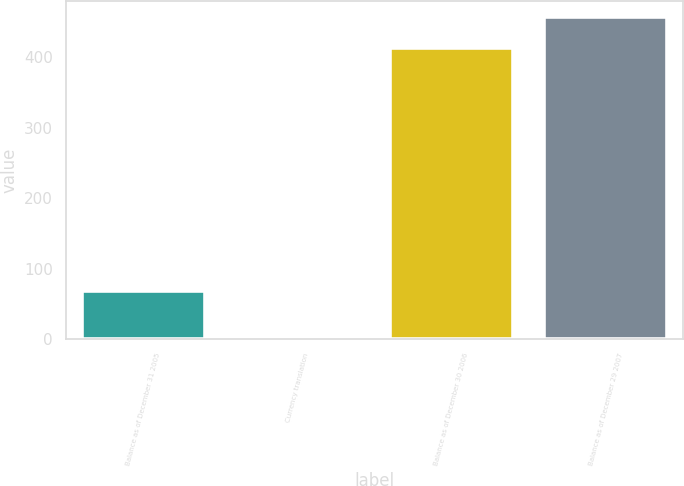Convert chart to OTSL. <chart><loc_0><loc_0><loc_500><loc_500><bar_chart><fcel>Balance as of December 31 2005<fcel>Currency translation<fcel>Balance as of December 30 2006<fcel>Balance as of December 29 2007<nl><fcel>69.1<fcel>0.2<fcel>413.5<fcel>456.76<nl></chart> 